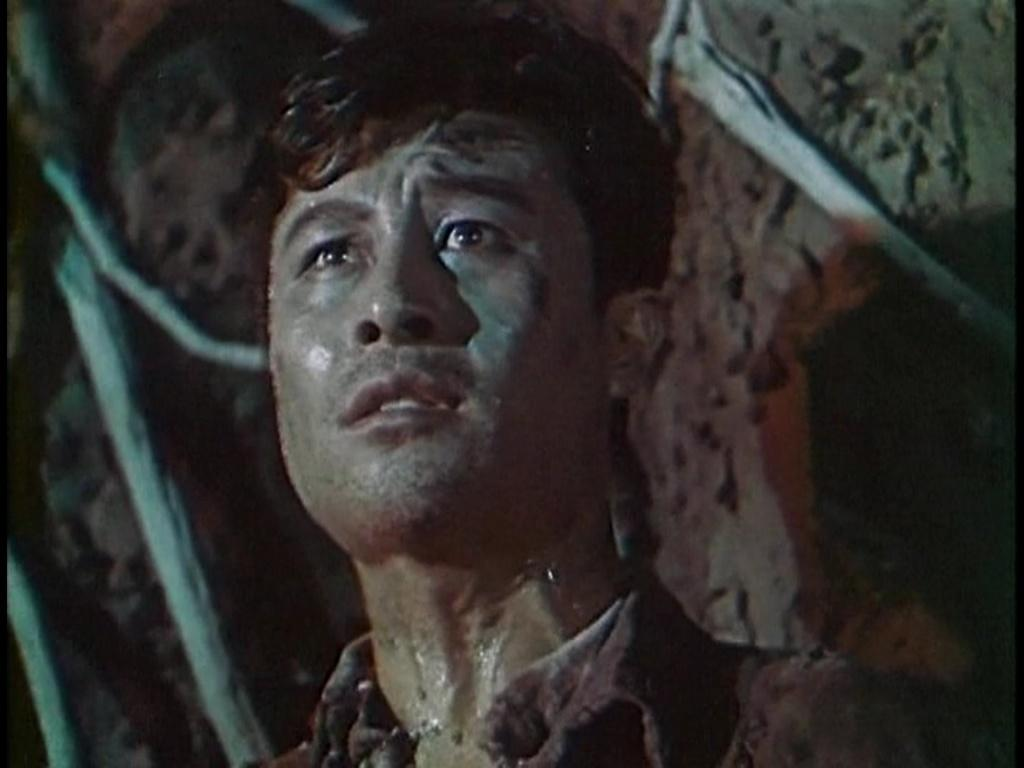What is the main subject of the image? There is a person standing in the middle of the image. What can be seen in the background of the image? There is a wall in the background of the image. What type of marble is being used to create the country in the image? There is no marble or country present in the image; it features a person standing in front of a wall. 